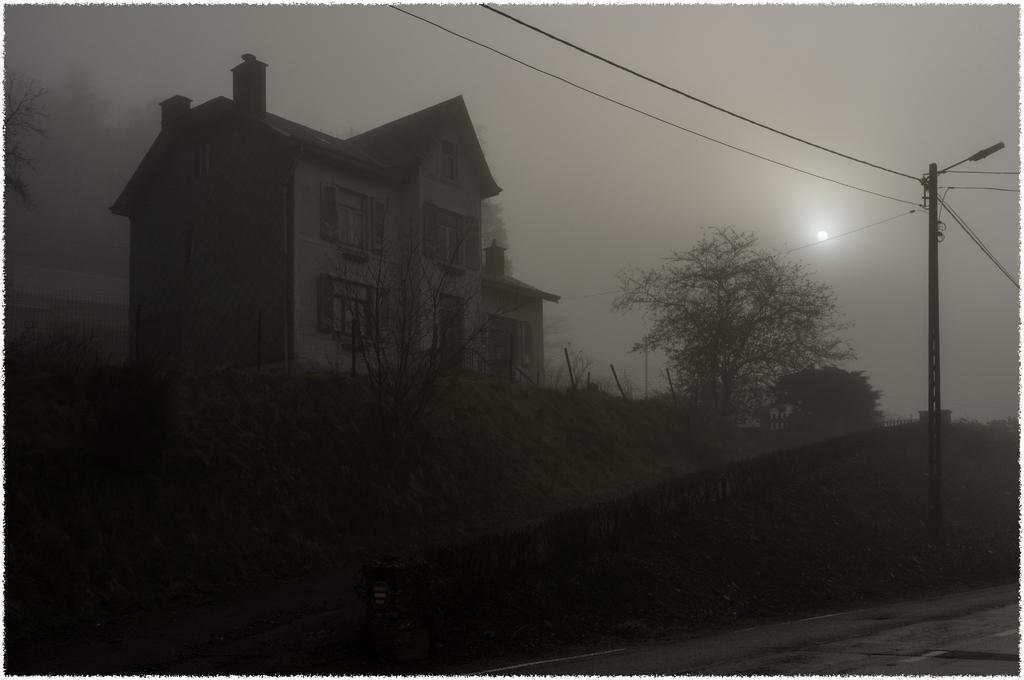Can you describe this image briefly? In the image there is a building and around the building there are trees and there is a current pole with some wires on the right side. 